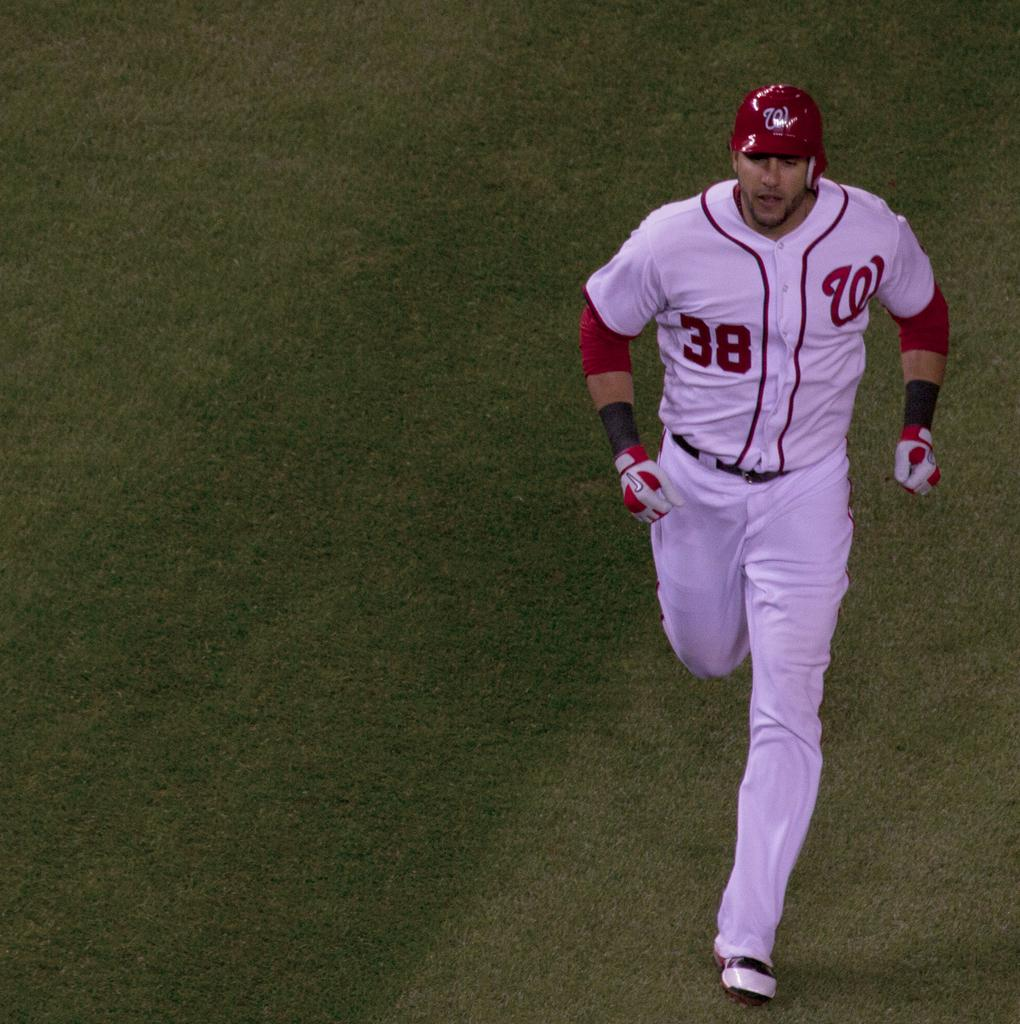<image>
Relay a brief, clear account of the picture shown. A washington nationals player with the number 38 on HIS JERSEY 